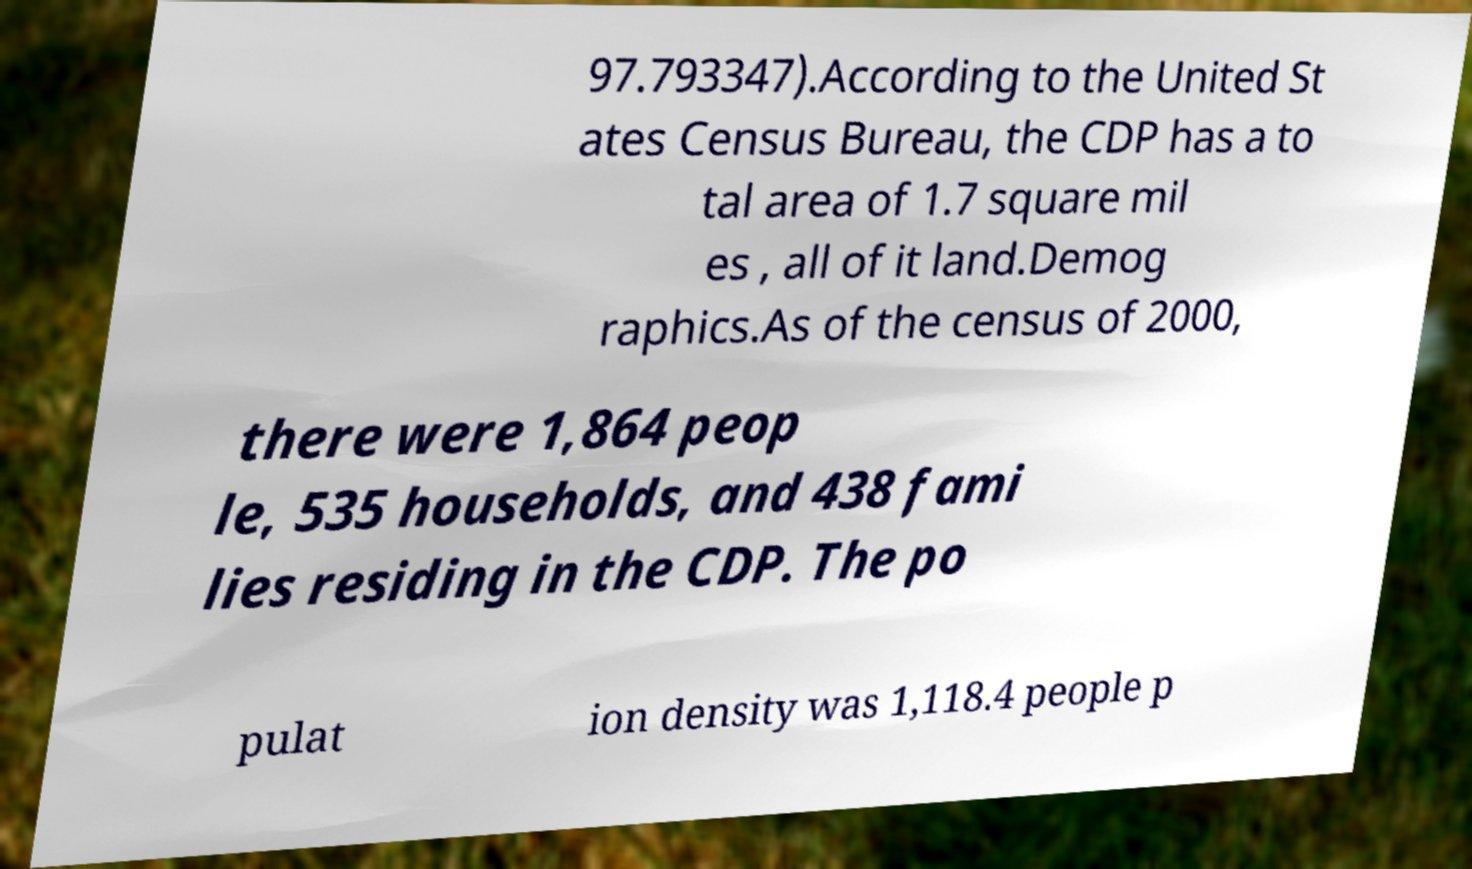Can you read and provide the text displayed in the image?This photo seems to have some interesting text. Can you extract and type it out for me? 97.793347).According to the United St ates Census Bureau, the CDP has a to tal area of 1.7 square mil es , all of it land.Demog raphics.As of the census of 2000, there were 1,864 peop le, 535 households, and 438 fami lies residing in the CDP. The po pulat ion density was 1,118.4 people p 